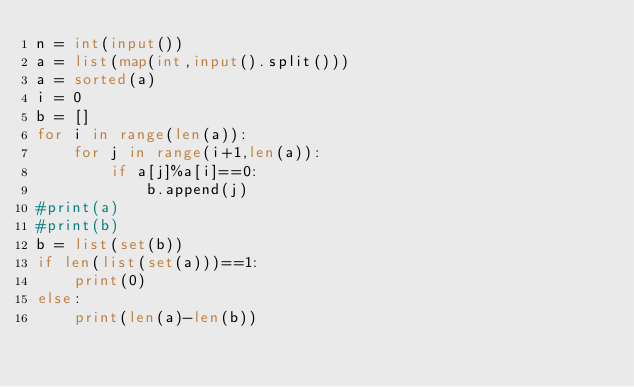<code> <loc_0><loc_0><loc_500><loc_500><_Python_>n = int(input())
a = list(map(int,input().split()))
a = sorted(a)
i = 0
b = []
for i in range(len(a)):
    for j in range(i+1,len(a)):
        if a[j]%a[i]==0:
            b.append(j)
#print(a)
#print(b)
b = list(set(b))
if len(list(set(a)))==1:
    print(0)
else:
    print(len(a)-len(b))</code> 